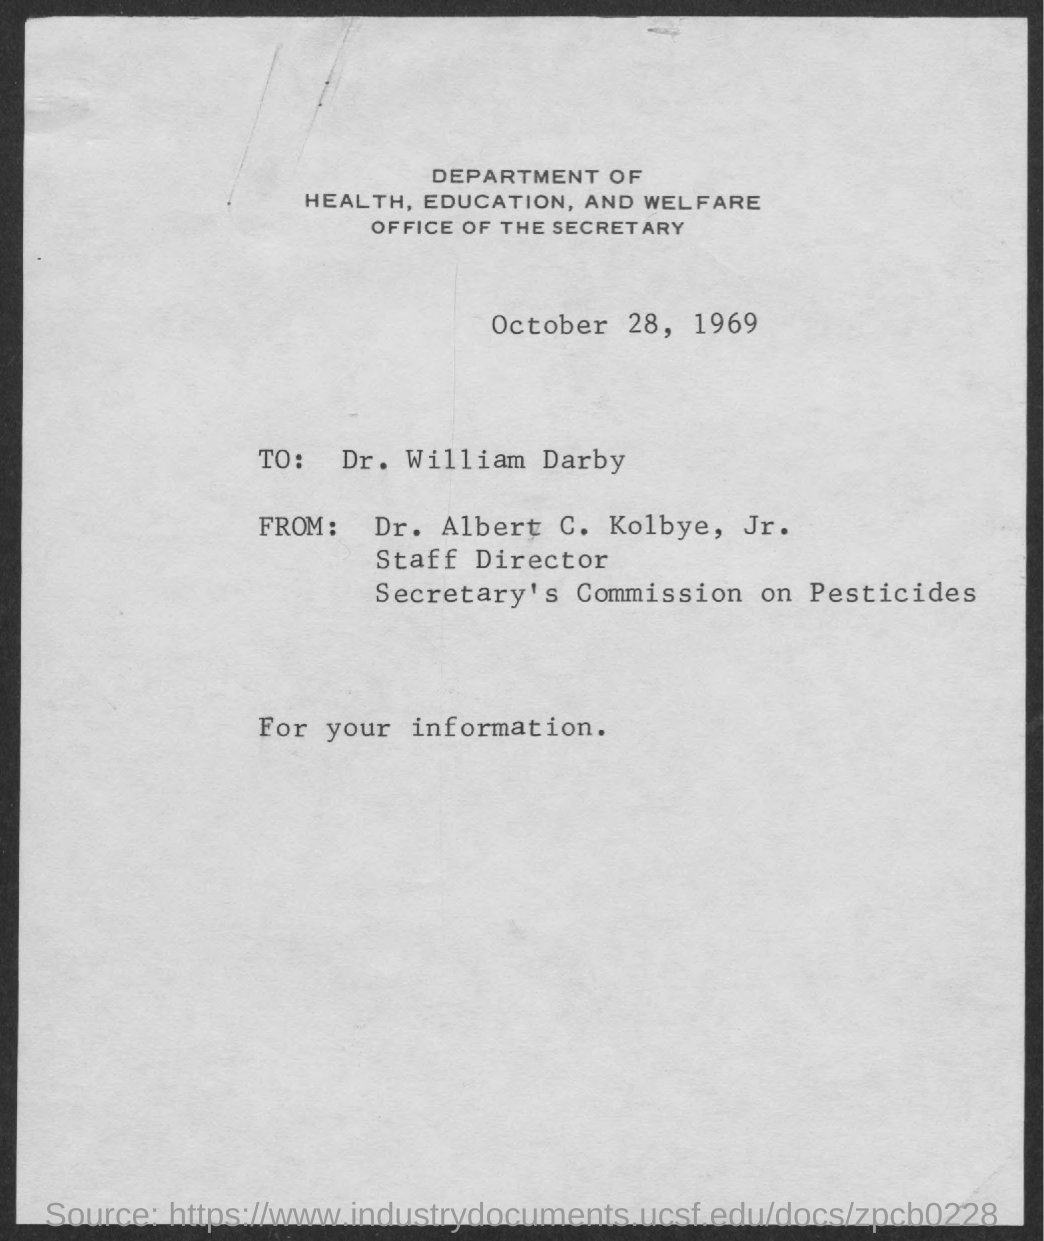What is the date mentioned in document?
Keep it short and to the point. October 28, 1969. To whom this letter is written to?
Provide a succinct answer. Dr. William Darby. Who is the staff director, secretary's commission on pesticides?
Give a very brief answer. Dr. Albert C. Kolbye, Jr. 